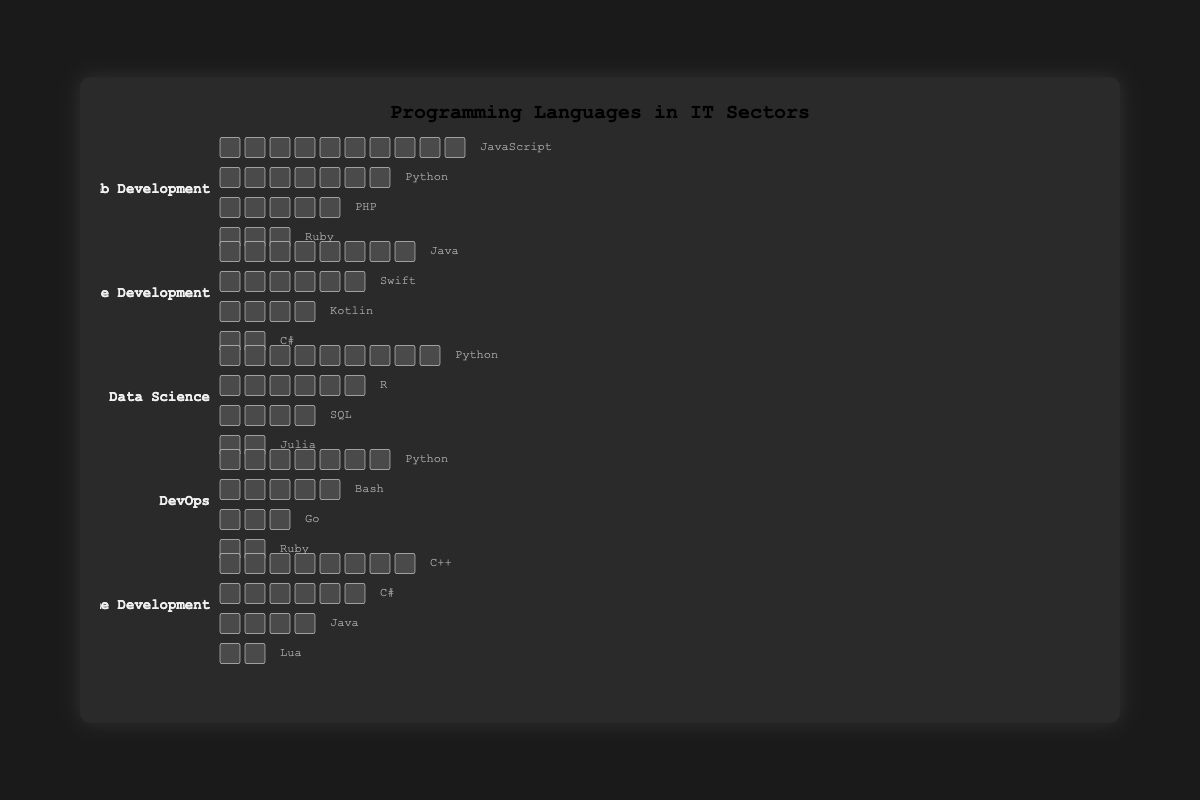What is the title of the figure? The title of the figure is placed at the top center of the visualization and reads "Programming Languages in IT Sectors".
Answer: Programming Languages in IT Sectors Which sector has the highest count of JavaScript usage? By looking at the sector labels and the counts of JavaScript icons, the highest JavaScript usage is found in the Web Development sector with 10 icons.
Answer: Web Development How many programming languages are displayed for the Mobile Development sector? The Mobile Development sector shows languages Java, Swift, Kotlin, and C#. By counting these, there are a total of 4 languages displayed for this sector.
Answer: 4 What is the sum of Python counts across all sectors? First, identify the counts of Python in each sector: Web Development (7), Data Science (9), and DevOps (7). Sum these counts: 7 + 9 + 7 = 23.
Answer: 23 Which sector uses the most diverse set of programming languages? To determine the diversity, count the number of different languages used in each sector. Web Development, Mobile Development, Data Science, DevOps, and Game Development each use 4 languages. All sectors use the same number of different languages.
Answer: All sectors use 4 languages Compare the use of Ruby in Web Development and DevOps. Which sector uses it more? Count the Ruby icons in each sector: Web Development (3) and DevOps (2). Web Development uses more Ruby than DevOps.
Answer: Web Development What is the difference in the number of Java icons between Mobile Development and Game Development? Count Java icons in Mobile Development (8) and Game Development (4). The difference is 8 - 4 = 4.
Answer: 4 Which sector has the highest count of a single language? Looking at the highest counts for each language in different sectors, JavaScript in Web Development has the highest count with 10 icons.
Answer: Web Development with JavaScript How many sectors utilize Python as one of their programming languages? Identify the sectors with Python: Web Development, Data Science, and DevOps. Count these sectors, resulting in 3 sectors.
Answer: 3 What is the average count of programming languages used in the Data Science sector? The counts for Data Science are Python (9), R (6), SQL (4), Julia (2). Summing these counts: 9 + 6 + 4 + 2 = 21 and dividing by the number of languages (4), the average is 21 / 4 = 5.25.
Answer: 5.25 